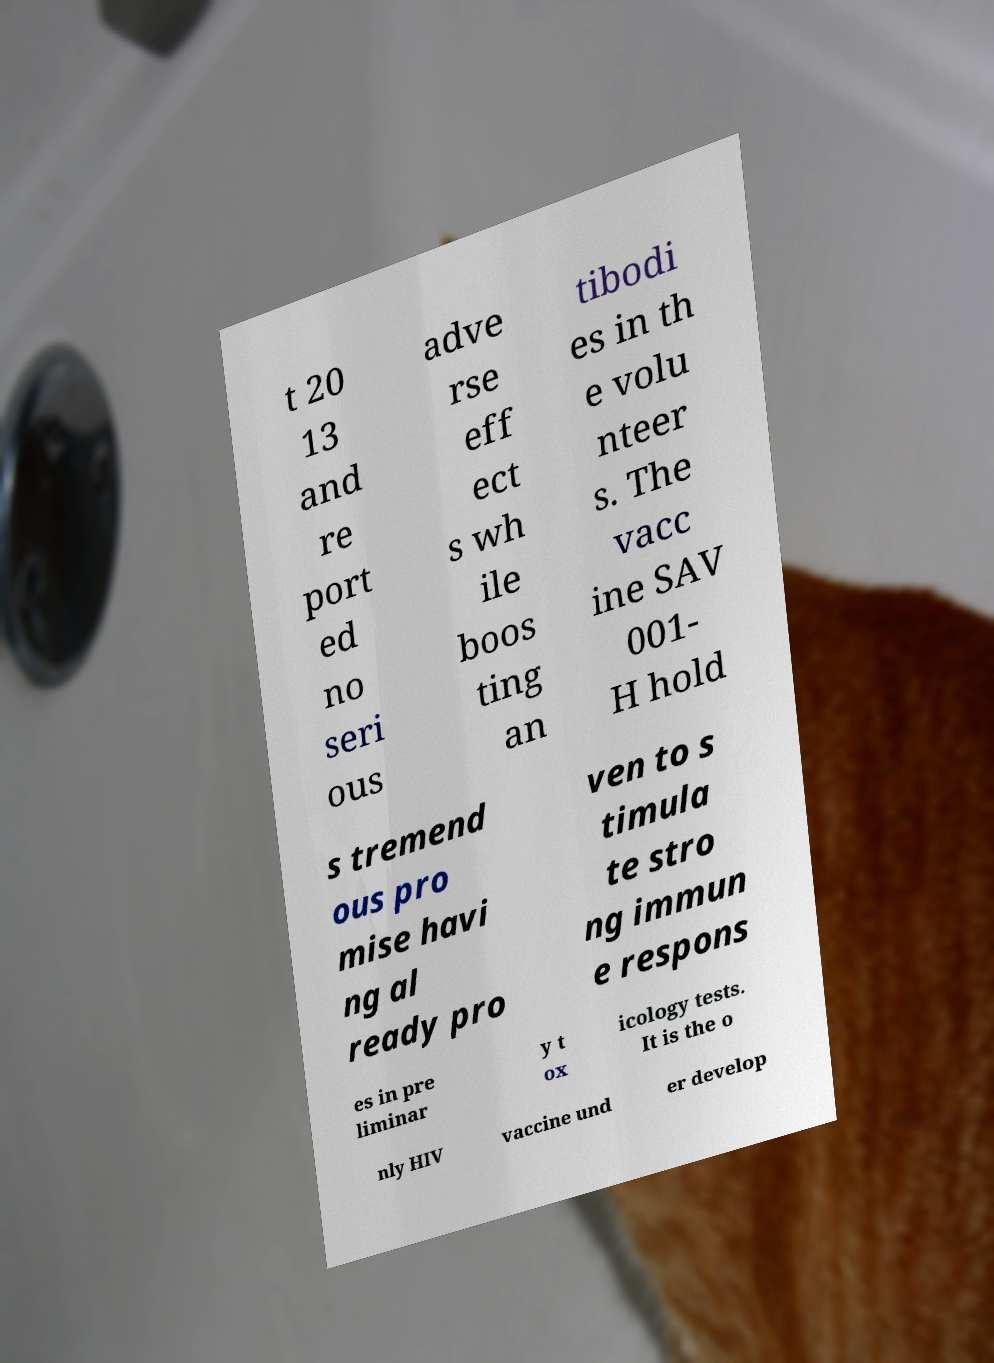I need the written content from this picture converted into text. Can you do that? t 20 13 and re port ed no seri ous adve rse eff ect s wh ile boos ting an tibodi es in th e volu nteer s. The vacc ine SAV 001- H hold s tremend ous pro mise havi ng al ready pro ven to s timula te stro ng immun e respons es in pre liminar y t ox icology tests. It is the o nly HIV vaccine und er develop 